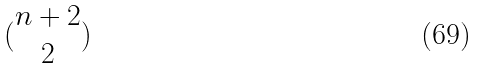Convert formula to latex. <formula><loc_0><loc_0><loc_500><loc_500>( \begin{matrix} n + 2 \\ 2 \end{matrix} )</formula> 